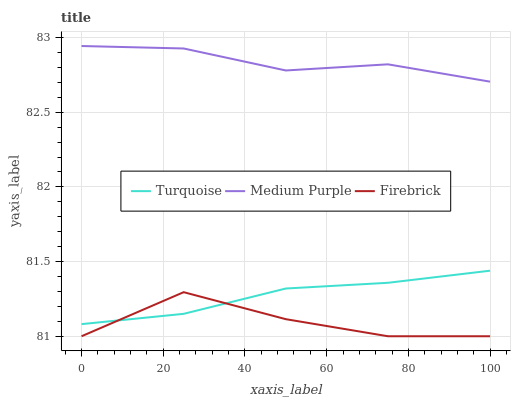Does Firebrick have the minimum area under the curve?
Answer yes or no. Yes. Does Medium Purple have the maximum area under the curve?
Answer yes or no. Yes. Does Turquoise have the minimum area under the curve?
Answer yes or no. No. Does Turquoise have the maximum area under the curve?
Answer yes or no. No. Is Turquoise the smoothest?
Answer yes or no. Yes. Is Firebrick the roughest?
Answer yes or no. Yes. Is Firebrick the smoothest?
Answer yes or no. No. Is Turquoise the roughest?
Answer yes or no. No. Does Firebrick have the lowest value?
Answer yes or no. Yes. Does Turquoise have the lowest value?
Answer yes or no. No. Does Medium Purple have the highest value?
Answer yes or no. Yes. Does Turquoise have the highest value?
Answer yes or no. No. Is Turquoise less than Medium Purple?
Answer yes or no. Yes. Is Medium Purple greater than Firebrick?
Answer yes or no. Yes. Does Turquoise intersect Firebrick?
Answer yes or no. Yes. Is Turquoise less than Firebrick?
Answer yes or no. No. Is Turquoise greater than Firebrick?
Answer yes or no. No. Does Turquoise intersect Medium Purple?
Answer yes or no. No. 